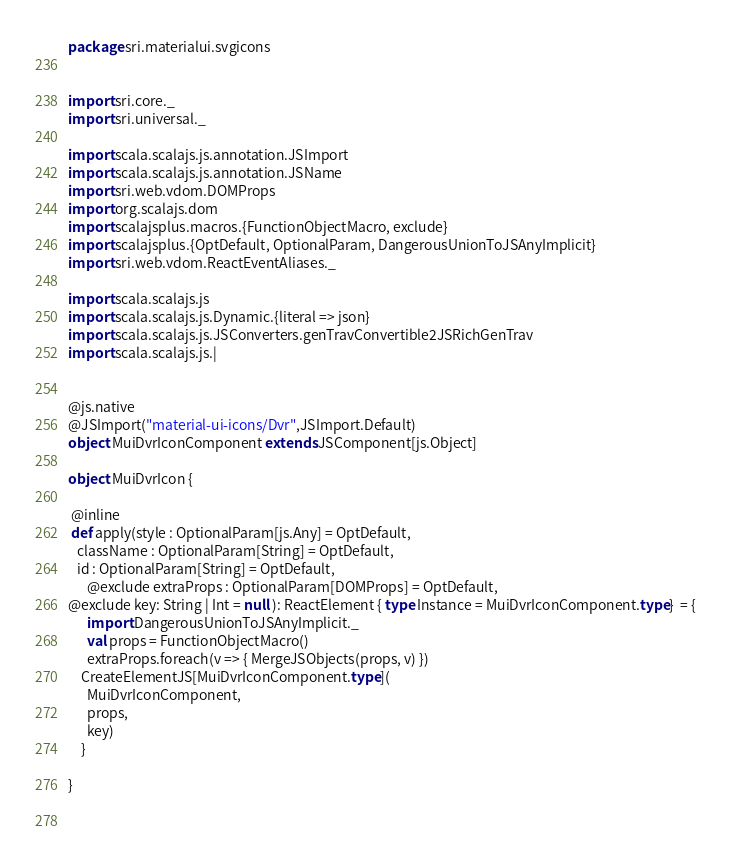<code> <loc_0><loc_0><loc_500><loc_500><_Scala_>package sri.materialui.svgicons


import sri.core._
import sri.universal._

import scala.scalajs.js.annotation.JSImport
import scala.scalajs.js.annotation.JSName
import sri.web.vdom.DOMProps
import org.scalajs.dom
import scalajsplus.macros.{FunctionObjectMacro, exclude}
import scalajsplus.{OptDefault, OptionalParam, DangerousUnionToJSAnyImplicit}
import sri.web.vdom.ReactEventAliases._

import scala.scalajs.js
import scala.scalajs.js.Dynamic.{literal => json}
import scala.scalajs.js.JSConverters.genTravConvertible2JSRichGenTrav
import scala.scalajs.js.|
     

@js.native
@JSImport("material-ui-icons/Dvr",JSImport.Default)
object MuiDvrIconComponent extends JSComponent[js.Object]

object MuiDvrIcon {

 @inline
 def apply(style : OptionalParam[js.Any] = OptDefault,
   className : OptionalParam[String] = OptDefault,
   id : OptionalParam[String] = OptDefault,
      @exclude extraProps : OptionalParam[DOMProps] = OptDefault,
@exclude key: String | Int = null ): ReactElement { type Instance = MuiDvrIconComponent.type}  = {
      import DangerousUnionToJSAnyImplicit._
      val props = FunctionObjectMacro()
      extraProps.foreach(v => { MergeJSObjects(props, v) })
    CreateElementJS[MuiDvrIconComponent.type](
      MuiDvrIconComponent,
      props,
      key)
    }

}

        
</code> 